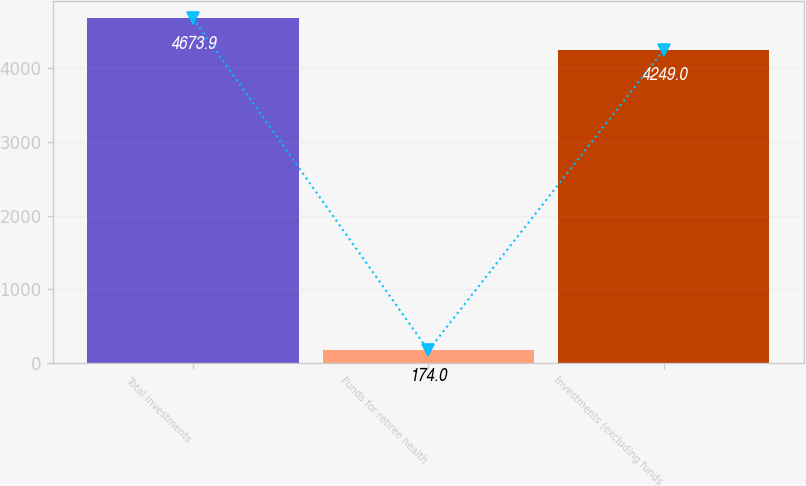Convert chart. <chart><loc_0><loc_0><loc_500><loc_500><bar_chart><fcel>Total investments<fcel>Funds for retiree health<fcel>Investments (excluding funds<nl><fcel>4673.9<fcel>174<fcel>4249<nl></chart> 